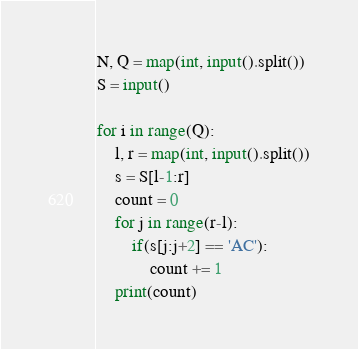Convert code to text. <code><loc_0><loc_0><loc_500><loc_500><_Python_>N, Q = map(int, input().split())
S = input()

for i in range(Q):
    l, r = map(int, input().split())
    s = S[l-1:r]
    count = 0
    for j in range(r-l):
        if(s[j:j+2] == 'AC'):
            count += 1
    print(count)
</code> 